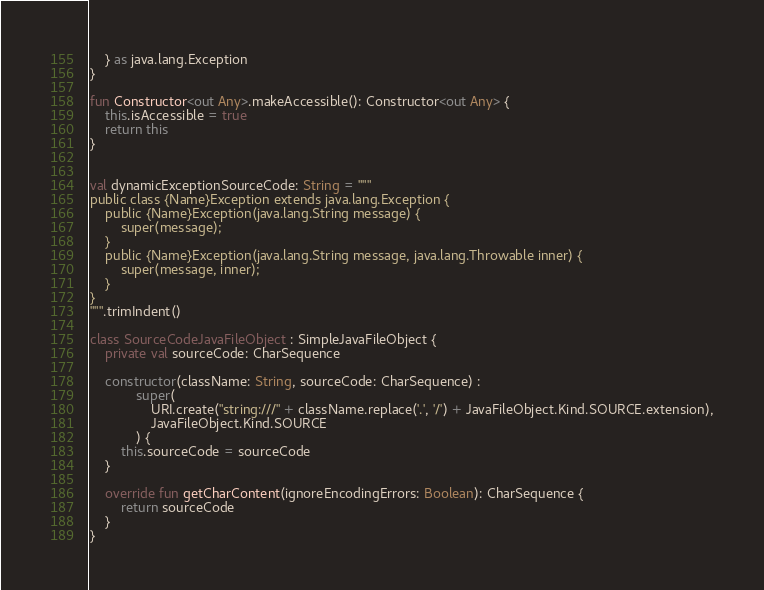Convert code to text. <code><loc_0><loc_0><loc_500><loc_500><_Kotlin_>    } as java.lang.Exception
}

fun Constructor<out Any>.makeAccessible(): Constructor<out Any> {
    this.isAccessible = true
    return this
}


val dynamicExceptionSourceCode: String = """
public class {Name}Exception extends java.lang.Exception {
    public {Name}Exception(java.lang.String message) {
        super(message);
    }
    public {Name}Exception(java.lang.String message, java.lang.Throwable inner) {
        super(message, inner);
    }
}
""".trimIndent()

class SourceCodeJavaFileObject : SimpleJavaFileObject {
    private val sourceCode: CharSequence

    constructor(className: String, sourceCode: CharSequence) :
            super(
                URI.create("string:///" + className.replace('.', '/') + JavaFileObject.Kind.SOURCE.extension),
                JavaFileObject.Kind.SOURCE
            ) {
        this.sourceCode = sourceCode
    }

    override fun getCharContent(ignoreEncodingErrors: Boolean): CharSequence {
        return sourceCode
    }
}</code> 